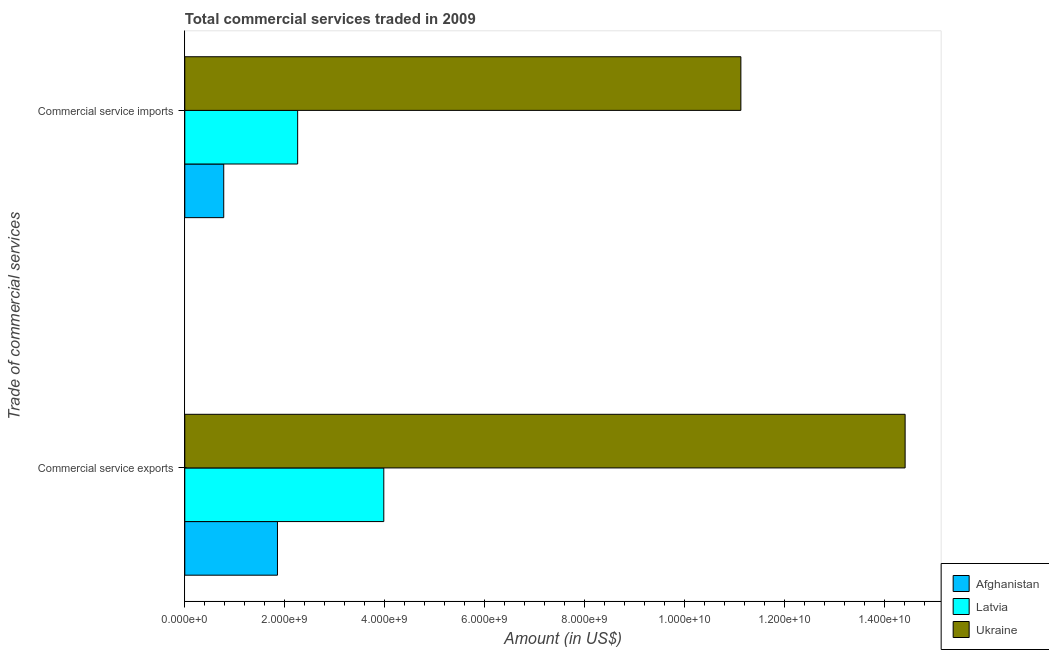How many groups of bars are there?
Provide a succinct answer. 2. Are the number of bars per tick equal to the number of legend labels?
Ensure brevity in your answer.  Yes. Are the number of bars on each tick of the Y-axis equal?
Provide a short and direct response. Yes. How many bars are there on the 2nd tick from the bottom?
Make the answer very short. 3. What is the label of the 1st group of bars from the top?
Provide a short and direct response. Commercial service imports. What is the amount of commercial service exports in Afghanistan?
Ensure brevity in your answer.  1.85e+09. Across all countries, what is the maximum amount of commercial service exports?
Your response must be concise. 1.44e+1. Across all countries, what is the minimum amount of commercial service imports?
Keep it short and to the point. 7.79e+08. In which country was the amount of commercial service imports maximum?
Make the answer very short. Ukraine. In which country was the amount of commercial service exports minimum?
Ensure brevity in your answer.  Afghanistan. What is the total amount of commercial service imports in the graph?
Offer a very short reply. 1.42e+1. What is the difference between the amount of commercial service exports in Ukraine and that in Afghanistan?
Provide a succinct answer. 1.26e+1. What is the difference between the amount of commercial service imports in Latvia and the amount of commercial service exports in Afghanistan?
Make the answer very short. 4.04e+08. What is the average amount of commercial service exports per country?
Give a very brief answer. 6.75e+09. What is the difference between the amount of commercial service exports and amount of commercial service imports in Latvia?
Give a very brief answer. 1.72e+09. In how many countries, is the amount of commercial service exports greater than 6400000000 US$?
Keep it short and to the point. 1. What is the ratio of the amount of commercial service imports in Ukraine to that in Latvia?
Give a very brief answer. 4.93. In how many countries, is the amount of commercial service imports greater than the average amount of commercial service imports taken over all countries?
Ensure brevity in your answer.  1. What does the 1st bar from the top in Commercial service exports represents?
Your answer should be very brief. Ukraine. What does the 3rd bar from the bottom in Commercial service exports represents?
Provide a short and direct response. Ukraine. How many bars are there?
Your answer should be compact. 6. What is the difference between two consecutive major ticks on the X-axis?
Your response must be concise. 2.00e+09. Are the values on the major ticks of X-axis written in scientific E-notation?
Your answer should be very brief. Yes. Does the graph contain any zero values?
Provide a succinct answer. No. What is the title of the graph?
Your answer should be compact. Total commercial services traded in 2009. What is the label or title of the Y-axis?
Your answer should be compact. Trade of commercial services. What is the Amount (in US$) of Afghanistan in Commercial service exports?
Offer a terse response. 1.85e+09. What is the Amount (in US$) in Latvia in Commercial service exports?
Ensure brevity in your answer.  3.98e+09. What is the Amount (in US$) of Ukraine in Commercial service exports?
Your answer should be compact. 1.44e+1. What is the Amount (in US$) of Afghanistan in Commercial service imports?
Your answer should be compact. 7.79e+08. What is the Amount (in US$) in Latvia in Commercial service imports?
Ensure brevity in your answer.  2.26e+09. What is the Amount (in US$) of Ukraine in Commercial service imports?
Your response must be concise. 1.11e+1. Across all Trade of commercial services, what is the maximum Amount (in US$) in Afghanistan?
Provide a short and direct response. 1.85e+09. Across all Trade of commercial services, what is the maximum Amount (in US$) of Latvia?
Offer a very short reply. 3.98e+09. Across all Trade of commercial services, what is the maximum Amount (in US$) in Ukraine?
Your answer should be compact. 1.44e+1. Across all Trade of commercial services, what is the minimum Amount (in US$) of Afghanistan?
Your answer should be compact. 7.79e+08. Across all Trade of commercial services, what is the minimum Amount (in US$) in Latvia?
Offer a very short reply. 2.26e+09. Across all Trade of commercial services, what is the minimum Amount (in US$) of Ukraine?
Keep it short and to the point. 1.11e+1. What is the total Amount (in US$) in Afghanistan in the graph?
Provide a succinct answer. 2.63e+09. What is the total Amount (in US$) in Latvia in the graph?
Your response must be concise. 6.24e+09. What is the total Amount (in US$) in Ukraine in the graph?
Make the answer very short. 2.55e+1. What is the difference between the Amount (in US$) of Afghanistan in Commercial service exports and that in Commercial service imports?
Make the answer very short. 1.08e+09. What is the difference between the Amount (in US$) in Latvia in Commercial service exports and that in Commercial service imports?
Your answer should be compact. 1.72e+09. What is the difference between the Amount (in US$) of Ukraine in Commercial service exports and that in Commercial service imports?
Give a very brief answer. 3.29e+09. What is the difference between the Amount (in US$) in Afghanistan in Commercial service exports and the Amount (in US$) in Latvia in Commercial service imports?
Your answer should be very brief. -4.04e+08. What is the difference between the Amount (in US$) in Afghanistan in Commercial service exports and the Amount (in US$) in Ukraine in Commercial service imports?
Provide a short and direct response. -9.27e+09. What is the difference between the Amount (in US$) in Latvia in Commercial service exports and the Amount (in US$) in Ukraine in Commercial service imports?
Give a very brief answer. -7.14e+09. What is the average Amount (in US$) of Afghanistan per Trade of commercial services?
Your response must be concise. 1.32e+09. What is the average Amount (in US$) of Latvia per Trade of commercial services?
Provide a succinct answer. 3.12e+09. What is the average Amount (in US$) of Ukraine per Trade of commercial services?
Keep it short and to the point. 1.28e+1. What is the difference between the Amount (in US$) in Afghanistan and Amount (in US$) in Latvia in Commercial service exports?
Make the answer very short. -2.13e+09. What is the difference between the Amount (in US$) in Afghanistan and Amount (in US$) in Ukraine in Commercial service exports?
Offer a very short reply. -1.26e+1. What is the difference between the Amount (in US$) in Latvia and Amount (in US$) in Ukraine in Commercial service exports?
Ensure brevity in your answer.  -1.04e+1. What is the difference between the Amount (in US$) of Afghanistan and Amount (in US$) of Latvia in Commercial service imports?
Your answer should be compact. -1.48e+09. What is the difference between the Amount (in US$) of Afghanistan and Amount (in US$) of Ukraine in Commercial service imports?
Make the answer very short. -1.03e+1. What is the difference between the Amount (in US$) in Latvia and Amount (in US$) in Ukraine in Commercial service imports?
Make the answer very short. -8.87e+09. What is the ratio of the Amount (in US$) in Afghanistan in Commercial service exports to that in Commercial service imports?
Offer a very short reply. 2.38. What is the ratio of the Amount (in US$) of Latvia in Commercial service exports to that in Commercial service imports?
Provide a short and direct response. 1.76. What is the ratio of the Amount (in US$) in Ukraine in Commercial service exports to that in Commercial service imports?
Give a very brief answer. 1.3. What is the difference between the highest and the second highest Amount (in US$) in Afghanistan?
Offer a terse response. 1.08e+09. What is the difference between the highest and the second highest Amount (in US$) in Latvia?
Make the answer very short. 1.72e+09. What is the difference between the highest and the second highest Amount (in US$) of Ukraine?
Provide a succinct answer. 3.29e+09. What is the difference between the highest and the lowest Amount (in US$) in Afghanistan?
Your answer should be very brief. 1.08e+09. What is the difference between the highest and the lowest Amount (in US$) of Latvia?
Your answer should be compact. 1.72e+09. What is the difference between the highest and the lowest Amount (in US$) in Ukraine?
Provide a succinct answer. 3.29e+09. 